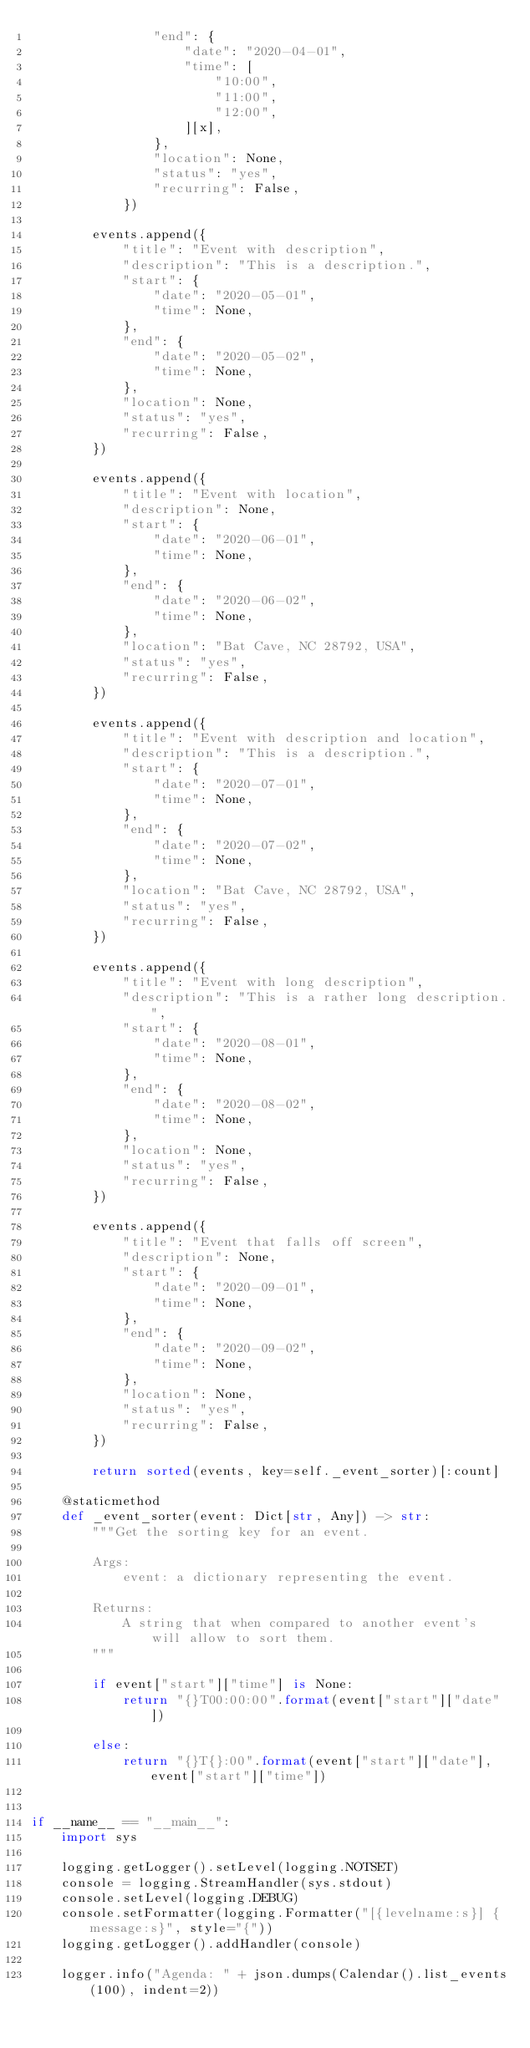Convert code to text. <code><loc_0><loc_0><loc_500><loc_500><_Python_>                "end": {
                    "date": "2020-04-01",
                    "time": [
                        "10:00",
                        "11:00",
                        "12:00",
                    ][x],
                },
                "location": None,
                "status": "yes",
                "recurring": False,
            })

        events.append({
            "title": "Event with description",
            "description": "This is a description.",
            "start": {
                "date": "2020-05-01",
                "time": None,
            },
            "end": {
                "date": "2020-05-02",
                "time": None,
            },
            "location": None,
            "status": "yes",
            "recurring": False,
        })

        events.append({
            "title": "Event with location",
            "description": None,
            "start": {
                "date": "2020-06-01",
                "time": None,
            },
            "end": {
                "date": "2020-06-02",
                "time": None,
            },
            "location": "Bat Cave, NC 28792, USA",
            "status": "yes",
            "recurring": False,
        })

        events.append({
            "title": "Event with description and location",
            "description": "This is a description.",
            "start": {
                "date": "2020-07-01",
                "time": None,
            },
            "end": {
                "date": "2020-07-02",
                "time": None,
            },
            "location": "Bat Cave, NC 28792, USA",
            "status": "yes",
            "recurring": False,
        })

        events.append({
            "title": "Event with long description",
            "description": "This is a rather long description.",
            "start": {
                "date": "2020-08-01",
                "time": None,
            },
            "end": {
                "date": "2020-08-02",
                "time": None,
            },
            "location": None,
            "status": "yes",
            "recurring": False,
        })

        events.append({
            "title": "Event that falls off screen",
            "description": None,
            "start": {
                "date": "2020-09-01",
                "time": None,
            },
            "end": {
                "date": "2020-09-02",
                "time": None,
            },
            "location": None,
            "status": "yes",
            "recurring": False,
        })

        return sorted(events, key=self._event_sorter)[:count]

    @staticmethod
    def _event_sorter(event: Dict[str, Any]) -> str:
        """Get the sorting key for an event.

        Args:
            event: a dictionary representing the event.

        Returns:
            A string that when compared to another event's will allow to sort them.
        """

        if event["start"]["time"] is None:
            return "{}T00:00:00".format(event["start"]["date"])

        else:
            return "{}T{}:00".format(event["start"]["date"], event["start"]["time"])


if __name__ == "__main__":
    import sys

    logging.getLogger().setLevel(logging.NOTSET)
    console = logging.StreamHandler(sys.stdout)
    console.setLevel(logging.DEBUG)
    console.setFormatter(logging.Formatter("[{levelname:s}] {message:s}", style="{"))
    logging.getLogger().addHandler(console)

    logger.info("Agenda: " + json.dumps(Calendar().list_events(100), indent=2))
</code> 